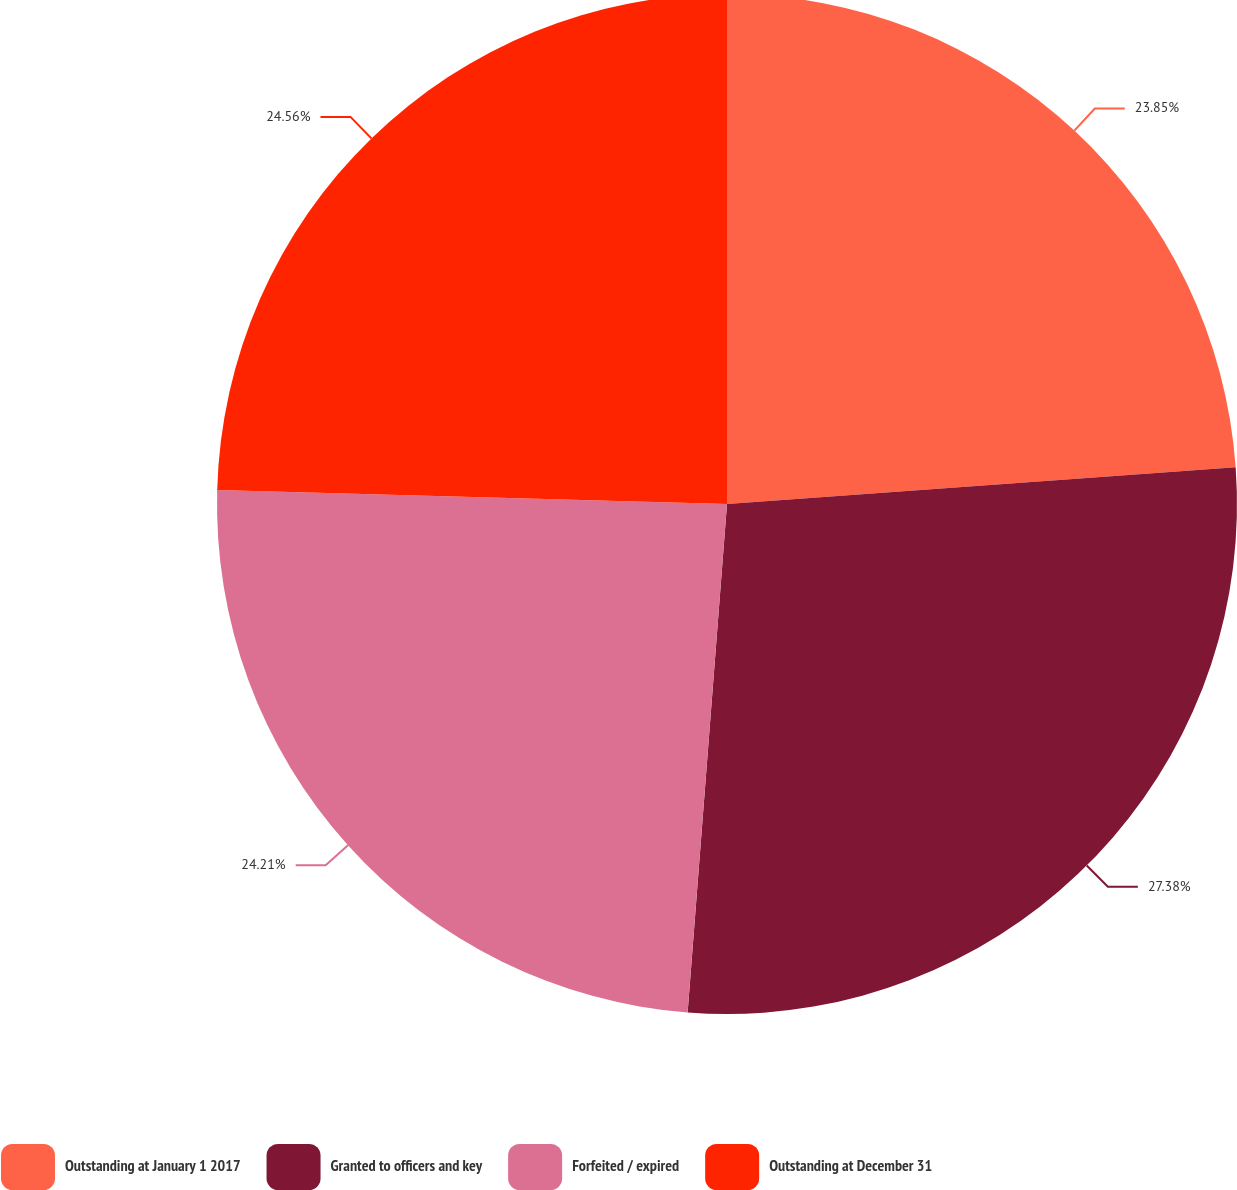Convert chart to OTSL. <chart><loc_0><loc_0><loc_500><loc_500><pie_chart><fcel>Outstanding at January 1 2017<fcel>Granted to officers and key<fcel>Forfeited / expired<fcel>Outstanding at December 31<nl><fcel>23.85%<fcel>27.38%<fcel>24.21%<fcel>24.56%<nl></chart> 